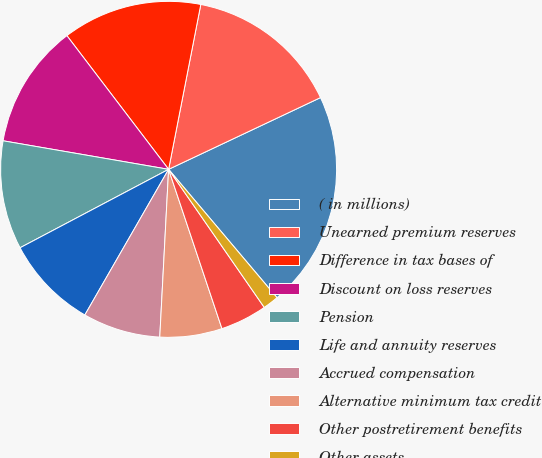Convert chart to OTSL. <chart><loc_0><loc_0><loc_500><loc_500><pie_chart><fcel>( in millions)<fcel>Unearned premium reserves<fcel>Difference in tax bases of<fcel>Discount on loss reserves<fcel>Pension<fcel>Life and annuity reserves<fcel>Accrued compensation<fcel>Alternative minimum tax credit<fcel>Other postretirement benefits<fcel>Other assets<nl><fcel>20.86%<fcel>14.91%<fcel>13.42%<fcel>11.93%<fcel>10.45%<fcel>8.96%<fcel>7.47%<fcel>5.98%<fcel>4.5%<fcel>1.52%<nl></chart> 